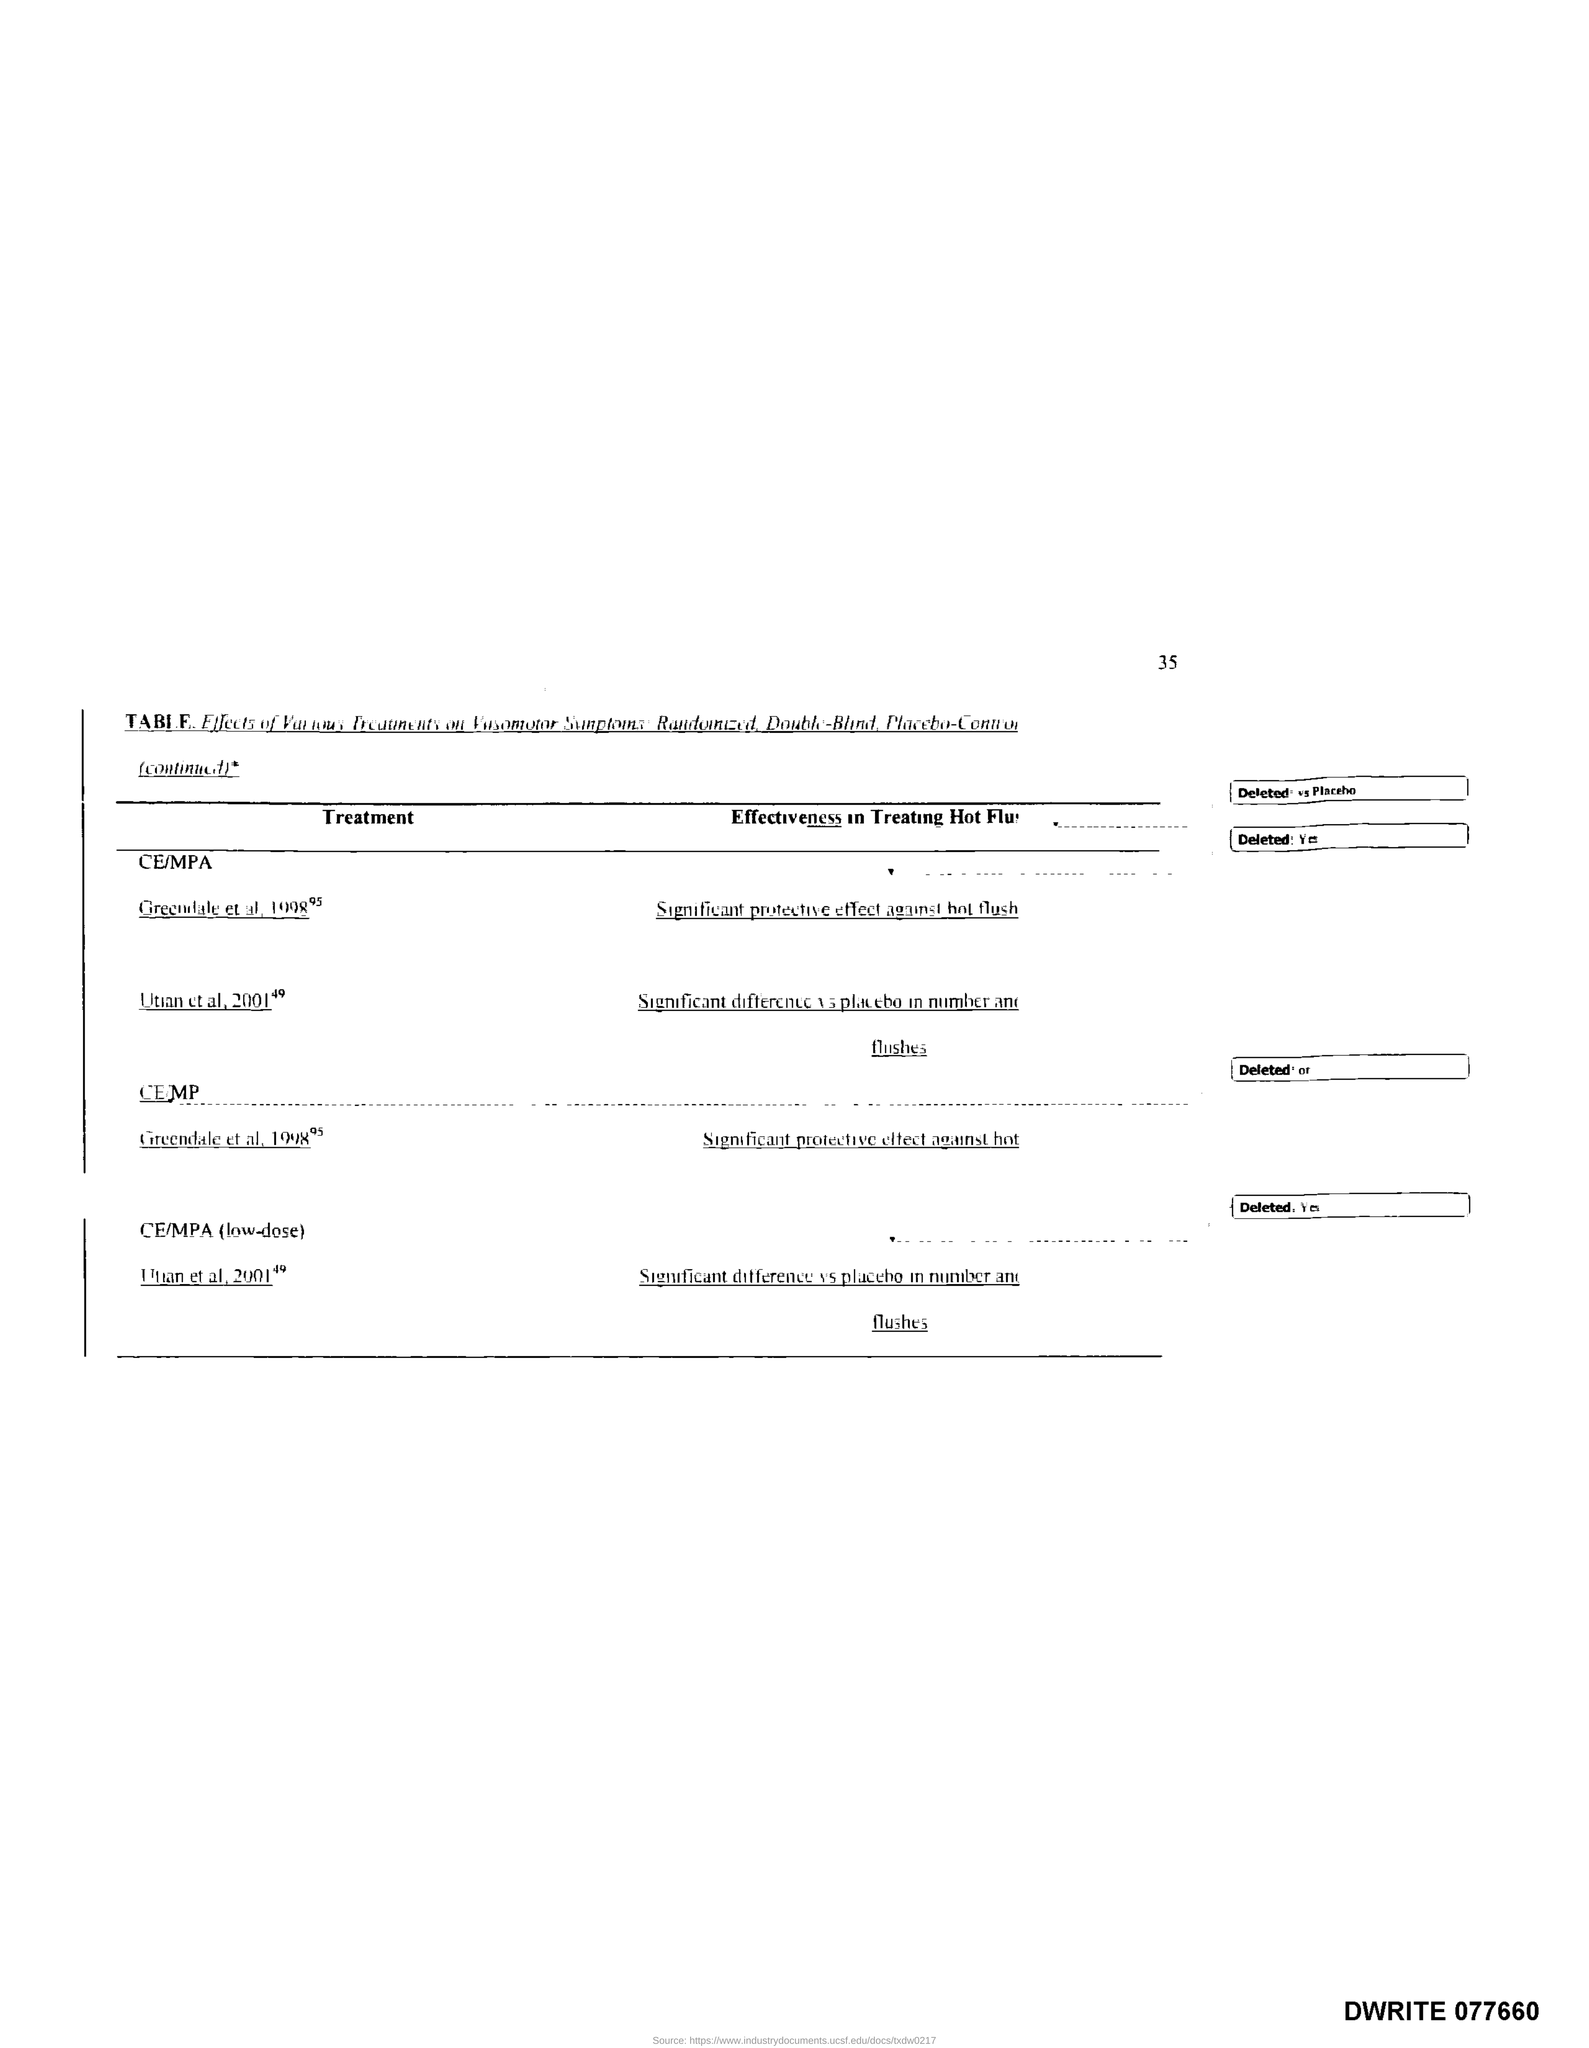What is the Page Number?
Your answer should be compact. 35. What is the Document Number?
Offer a very short reply. DWRITE 077660. 